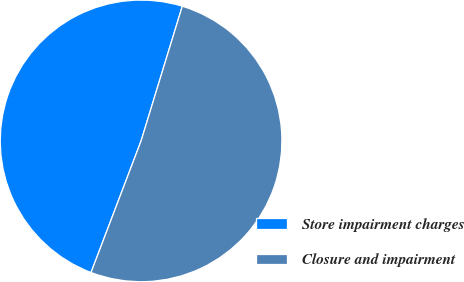<chart> <loc_0><loc_0><loc_500><loc_500><pie_chart><fcel>Store impairment charges<fcel>Closure and impairment<nl><fcel>48.94%<fcel>51.06%<nl></chart> 